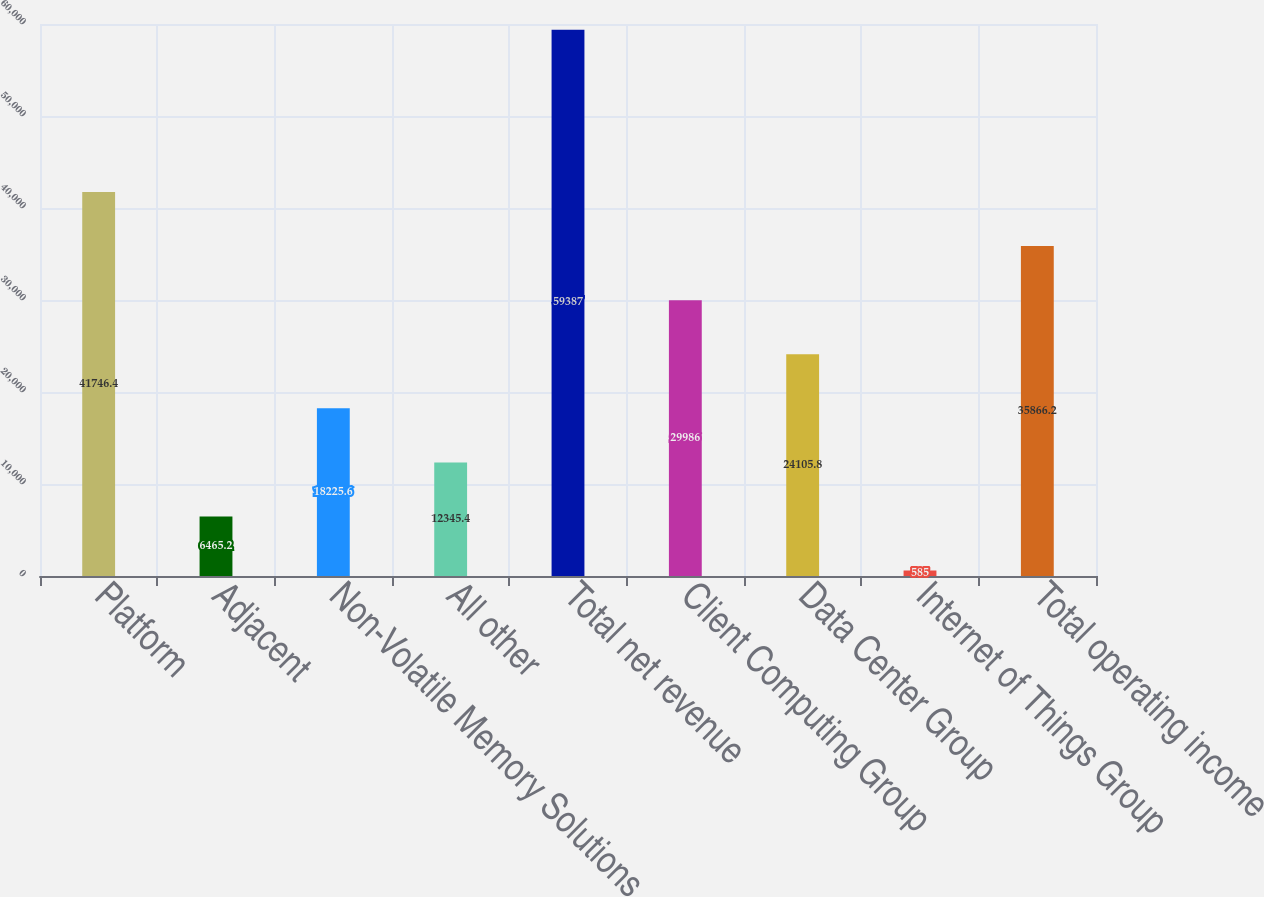Convert chart. <chart><loc_0><loc_0><loc_500><loc_500><bar_chart><fcel>Platform<fcel>Adjacent<fcel>Non-Volatile Memory Solutions<fcel>All other<fcel>Total net revenue<fcel>Client Computing Group<fcel>Data Center Group<fcel>Internet of Things Group<fcel>Total operating income<nl><fcel>41746.4<fcel>6465.2<fcel>18225.6<fcel>12345.4<fcel>59387<fcel>29986<fcel>24105.8<fcel>585<fcel>35866.2<nl></chart> 